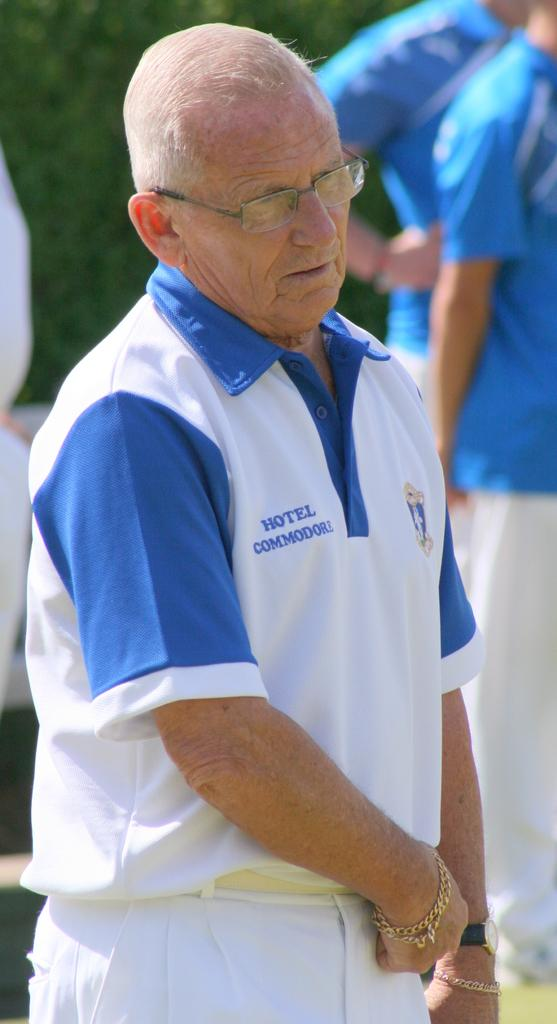<image>
Describe the image concisely. the word hotel that is on a person's shirt 